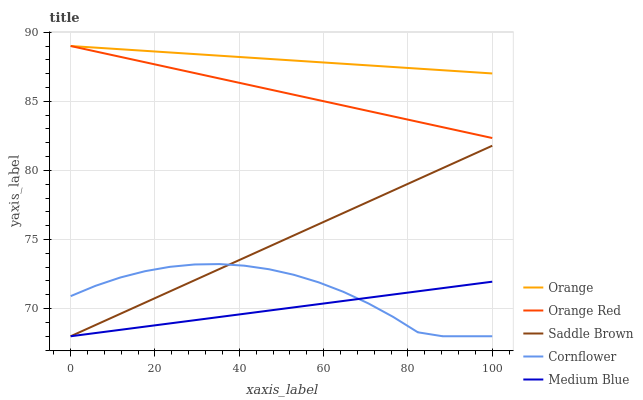Does Cornflower have the minimum area under the curve?
Answer yes or no. No. Does Cornflower have the maximum area under the curve?
Answer yes or no. No. Is Cornflower the smoothest?
Answer yes or no. No. Is Medium Blue the roughest?
Answer yes or no. No. Does Orange Red have the lowest value?
Answer yes or no. No. Does Cornflower have the highest value?
Answer yes or no. No. Is Medium Blue less than Orange Red?
Answer yes or no. Yes. Is Orange Red greater than Medium Blue?
Answer yes or no. Yes. Does Medium Blue intersect Orange Red?
Answer yes or no. No. 